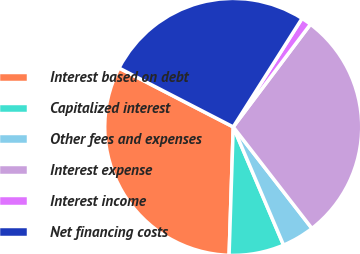Convert chart to OTSL. <chart><loc_0><loc_0><loc_500><loc_500><pie_chart><fcel>Interest based on debt<fcel>Capitalized interest<fcel>Other fees and expenses<fcel>Interest expense<fcel>Interest income<fcel>Net financing costs<nl><fcel>32.07%<fcel>6.92%<fcel>4.09%<fcel>29.24%<fcel>1.27%<fcel>26.42%<nl></chart> 